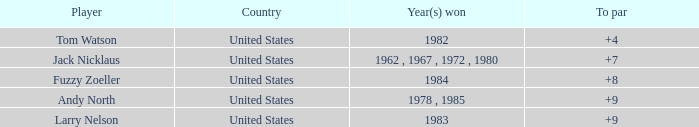Write the full table. {'header': ['Player', 'Country', 'Year(s) won', 'To par'], 'rows': [['Tom Watson', 'United States', '1982', '+4'], ['Jack Nicklaus', 'United States', '1962 , 1967 , 1972 , 1980', '+7'], ['Fuzzy Zoeller', 'United States', '1984', '+8'], ['Andy North', 'United States', '1978 , 1985', '+9'], ['Larry Nelson', 'United States', '1983', '+9']]} What is the sum for the player who won in the year 1982? 148.0. 